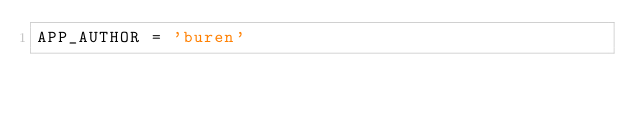Convert code to text. <code><loc_0><loc_0><loc_500><loc_500><_Ruby_>APP_AUTHOR = 'buren'
</code> 